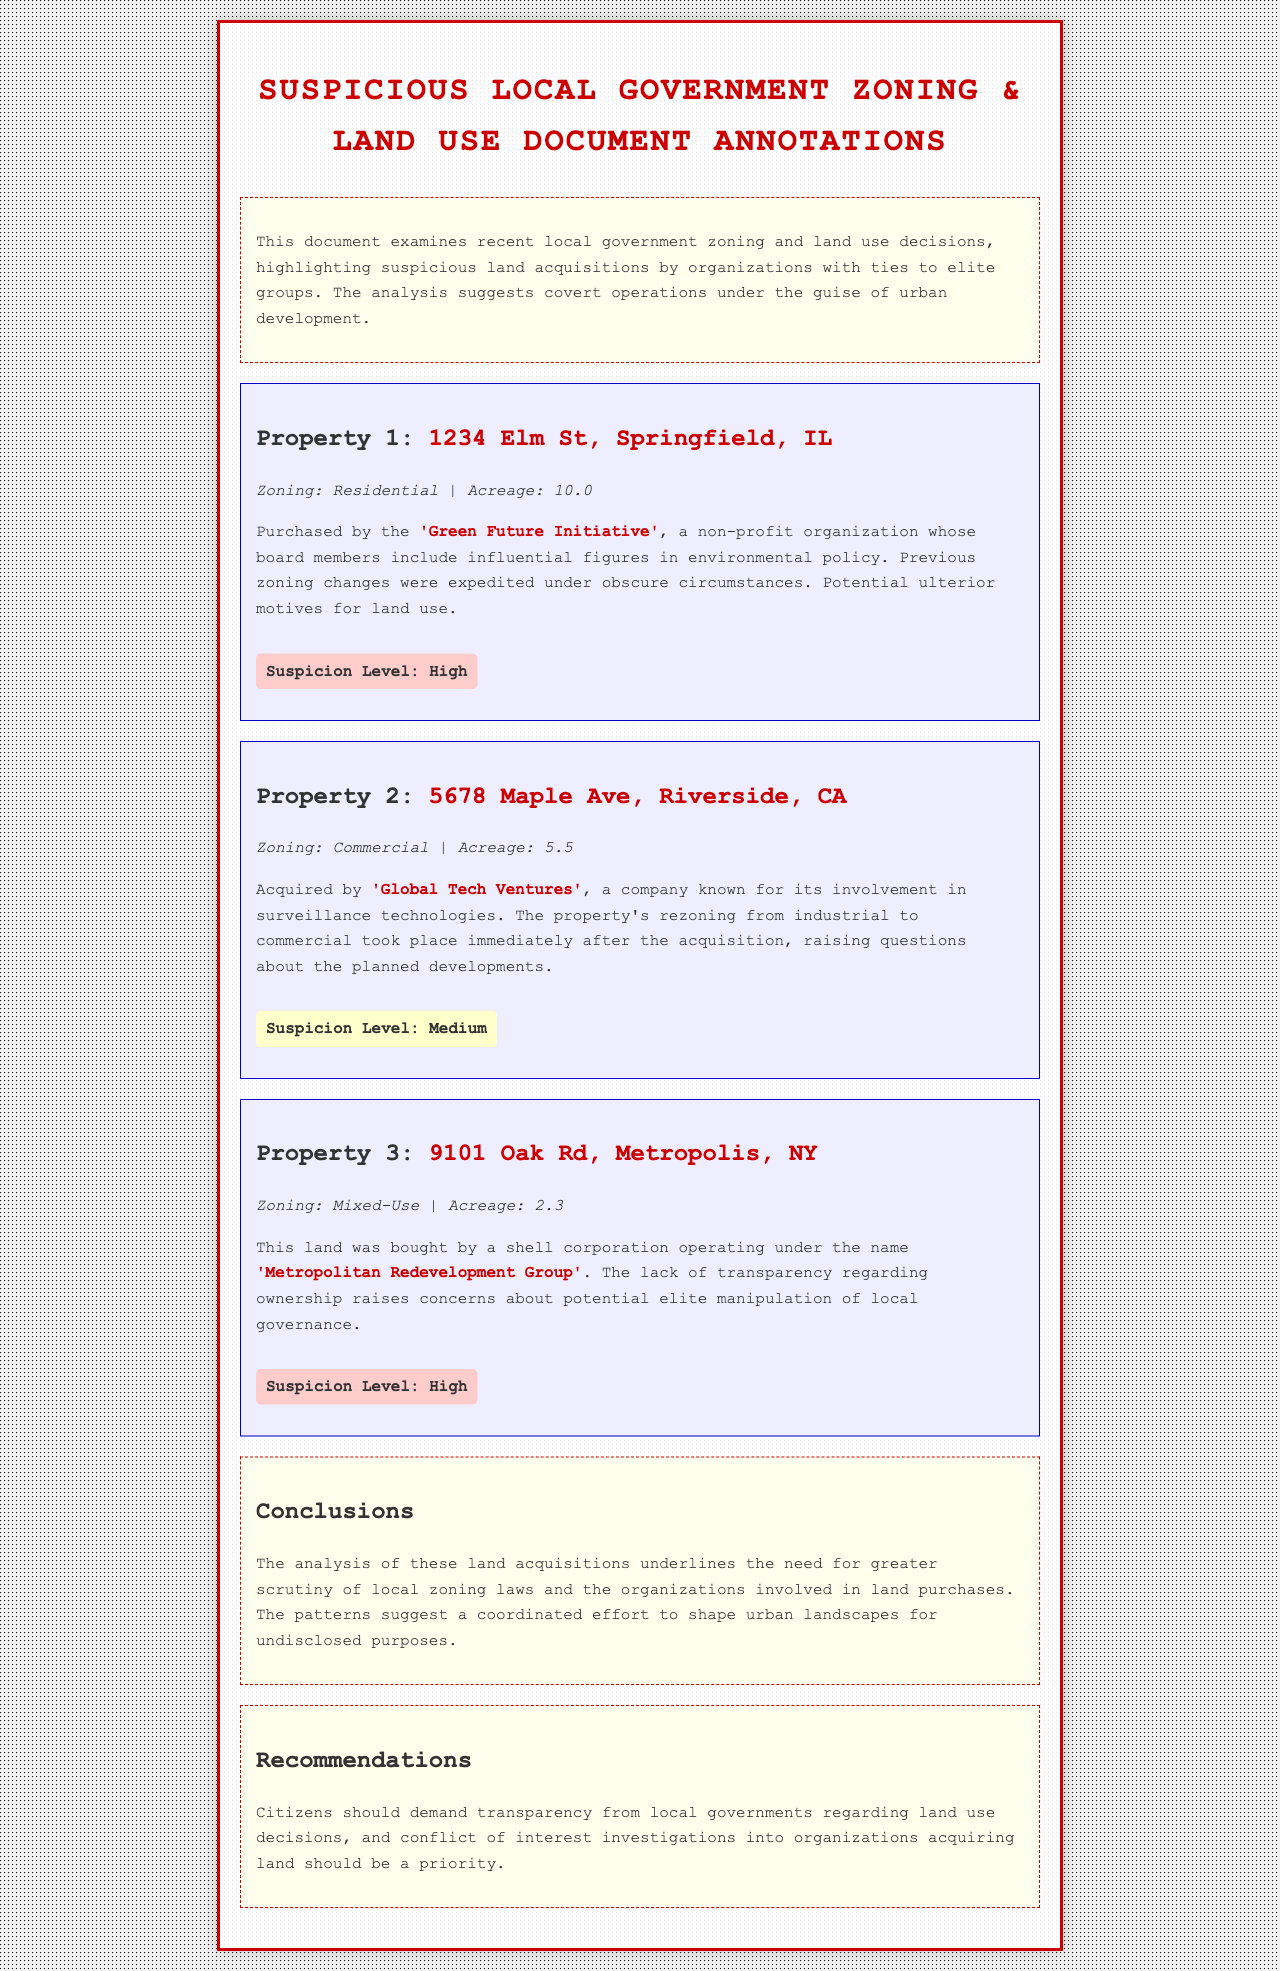What is the address of Property 1? The address of Property 1 is mentioned in the heading of the section, which is 1234 Elm St, Springfield, IL.
Answer: 1234 Elm St, Springfield, IL What is the acreage of Property 2? The acreage is specified in the property details section for Property 2, which states it is 5.5 acres.
Answer: 5.5 Who acquired Property 3? The acquisition information for Property 3 identifies the entity that purchased it, which is the Metropolitan Redevelopment Group.
Answer: Metropolitan Redevelopment Group What level of suspicion is associated with Property 1? The suspicion level for Property 1 is indicated at the end of the description, described as high.
Answer: High What was the previous zoning type for the property acquired by Global Tech Ventures? The document mentions that the property's zoning changed from industrial to commercial after acquisition, providing insight into its prior zoning.
Answer: Industrial What background is provided for the Green Future Initiative? The document notes that board members include influential figures in environmental policy, hinting at the organization's connections.
Answer: Environmental policy How many properties are highlighted in the document? By summing the properties listed in their respective sections, it can be identified that there are three properties discussed.
Answer: Three What does the conclusion suggest about urban landscapes? The conclusion infers that there is a coordinated effort to shape urban landscapes for undisclosed purposes.
Answer: Covert operations What is recommended for citizens regarding land use decisions? The recommendations emphasize the need for citizens to demand transparency from local governments concerning land use decisions.
Answer: Transparency 